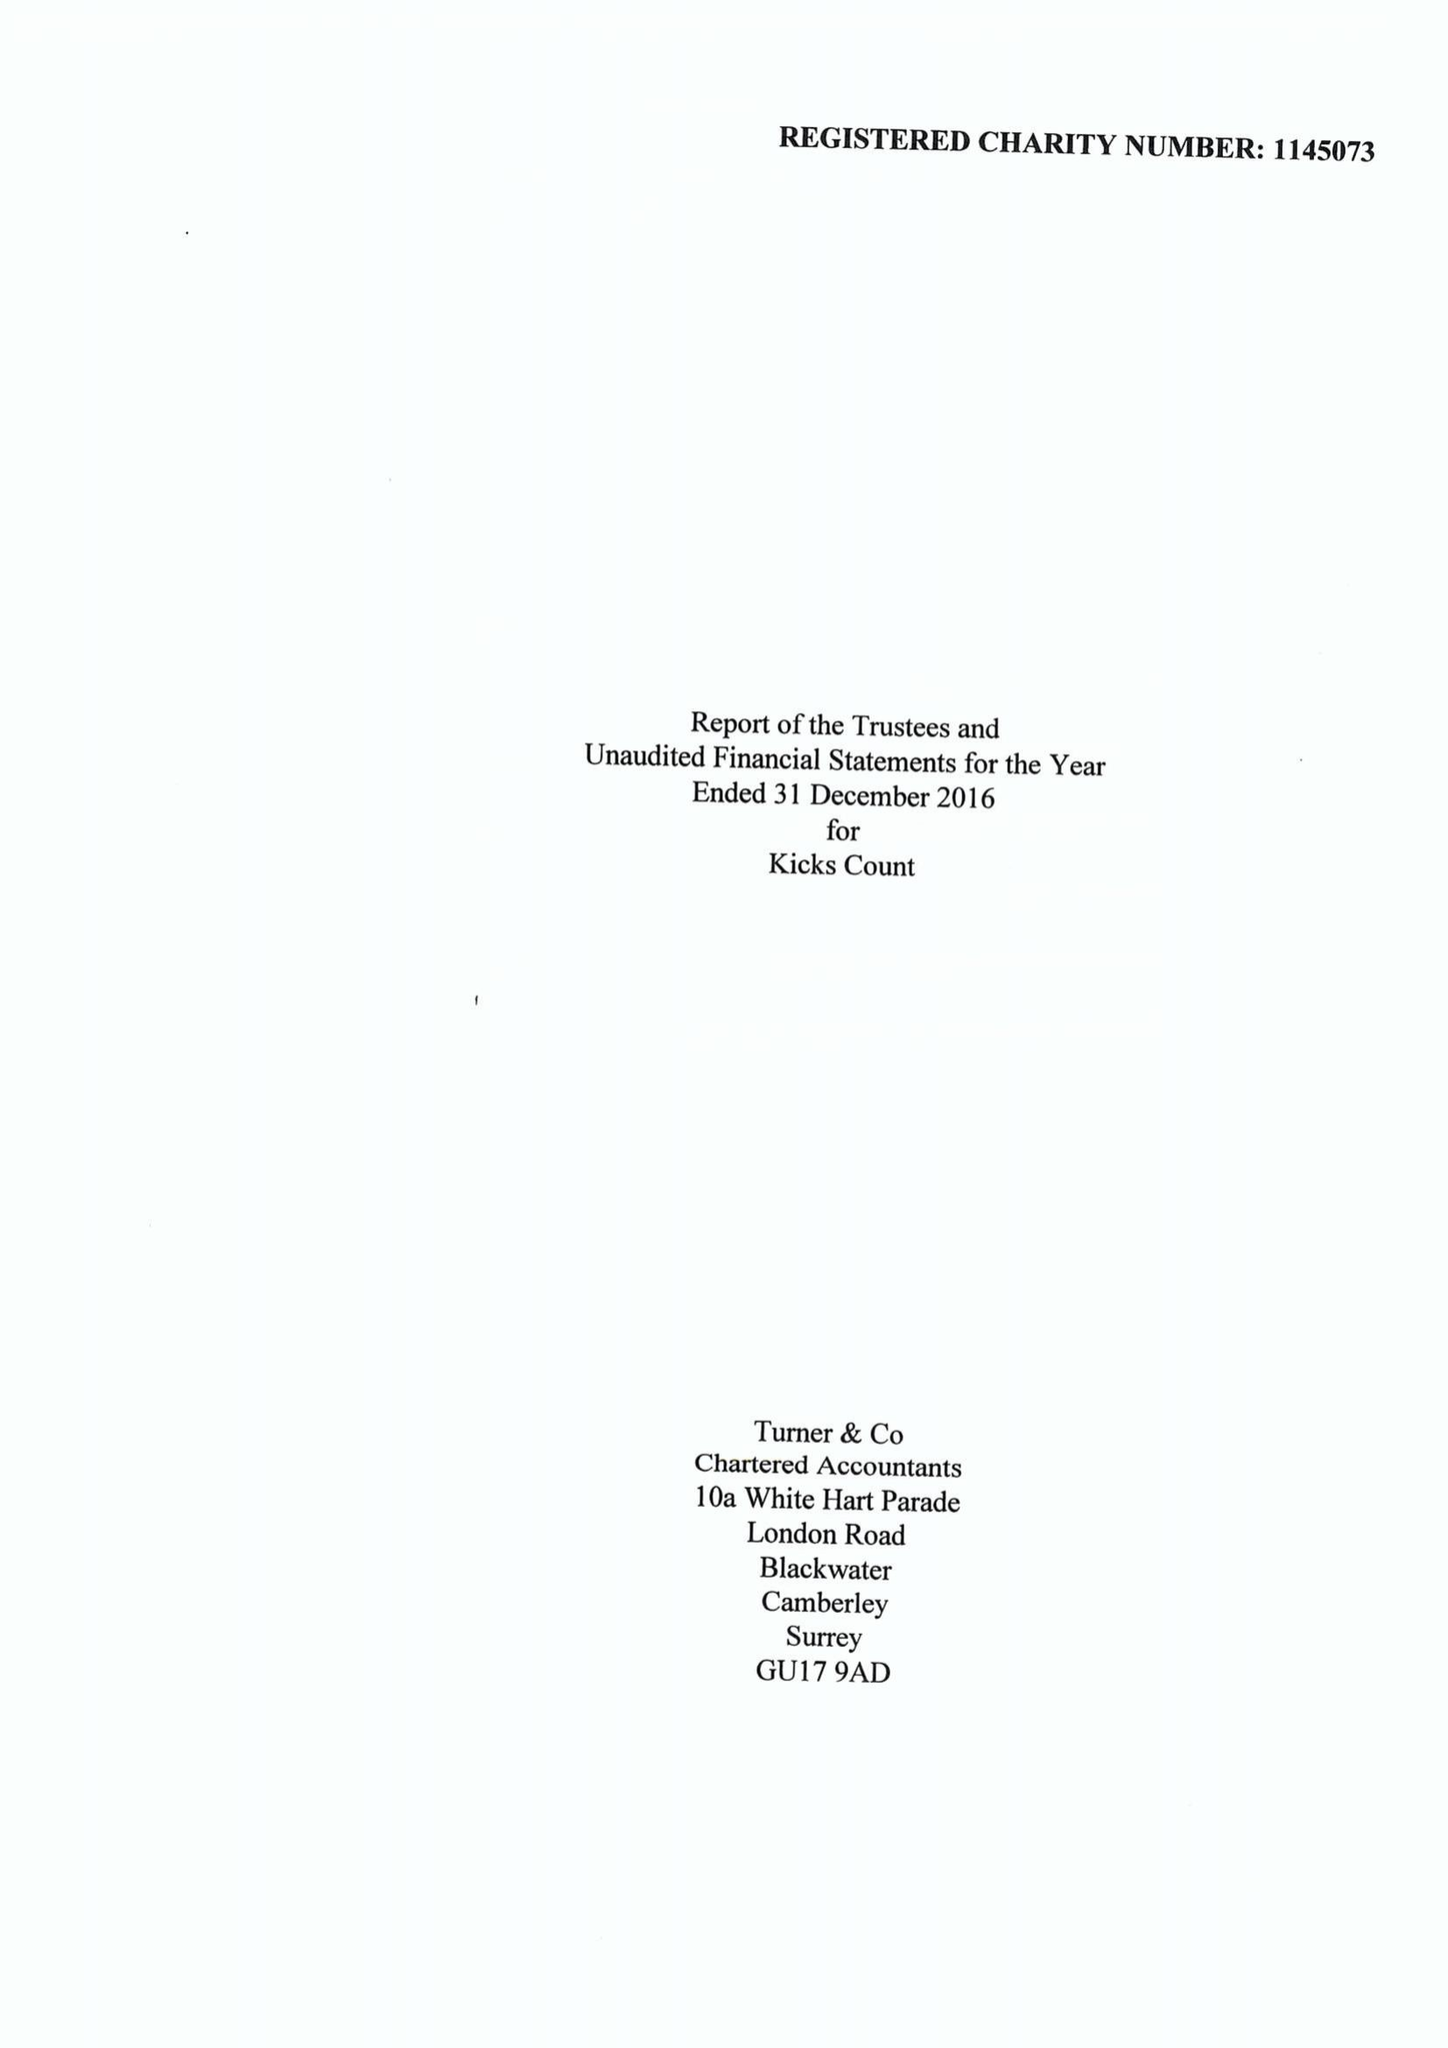What is the value for the spending_annually_in_british_pounds?
Answer the question using a single word or phrase. 178525.00 